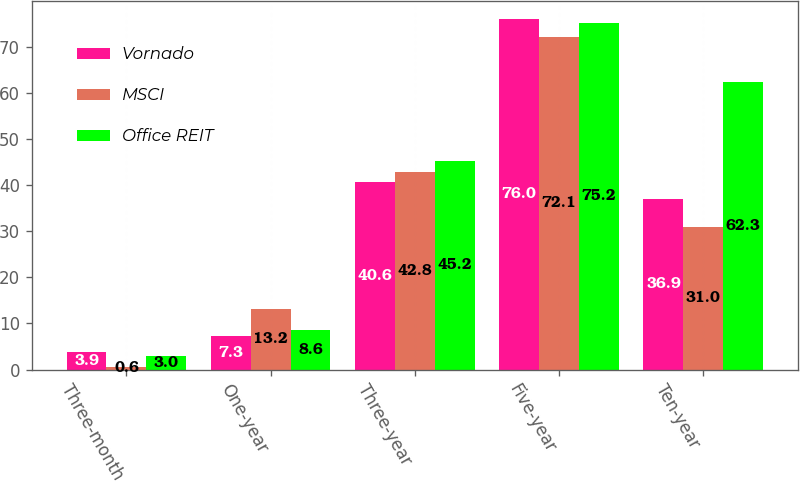Convert chart to OTSL. <chart><loc_0><loc_0><loc_500><loc_500><stacked_bar_chart><ecel><fcel>Three-month<fcel>One-year<fcel>Three-year<fcel>Five-year<fcel>Ten-year<nl><fcel>Vornado<fcel>3.9<fcel>7.3<fcel>40.6<fcel>76<fcel>36.9<nl><fcel>MSCI<fcel>0.6<fcel>13.2<fcel>42.8<fcel>72.1<fcel>31<nl><fcel>Office REIT<fcel>3<fcel>8.6<fcel>45.2<fcel>75.2<fcel>62.3<nl></chart> 